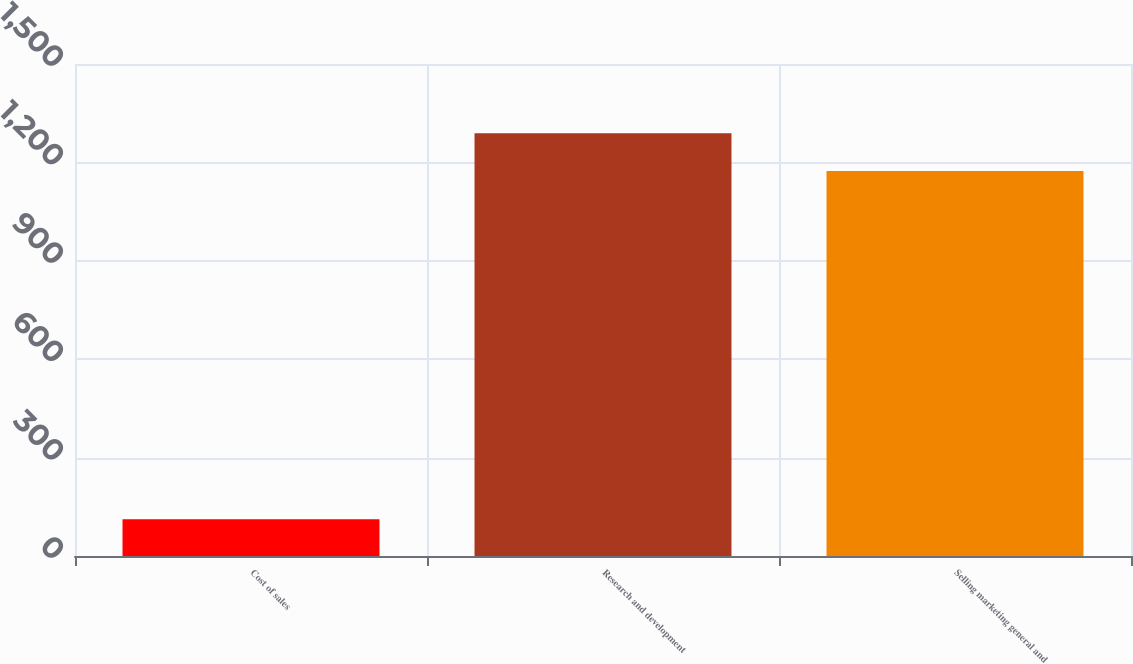Convert chart. <chart><loc_0><loc_0><loc_500><loc_500><bar_chart><fcel>Cost of sales<fcel>Research and development<fcel>Selling marketing general and<nl><fcel>112<fcel>1288.7<fcel>1174<nl></chart> 